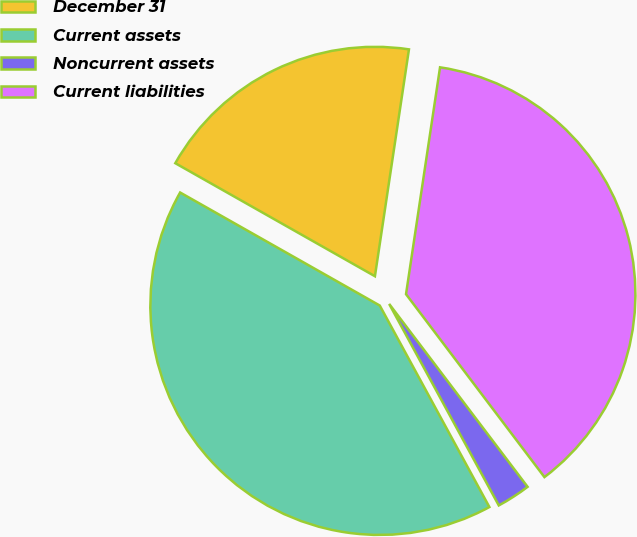Convert chart. <chart><loc_0><loc_0><loc_500><loc_500><pie_chart><fcel>December 31<fcel>Current assets<fcel>Noncurrent assets<fcel>Current liabilities<nl><fcel>19.17%<fcel>41.13%<fcel>2.38%<fcel>37.32%<nl></chart> 